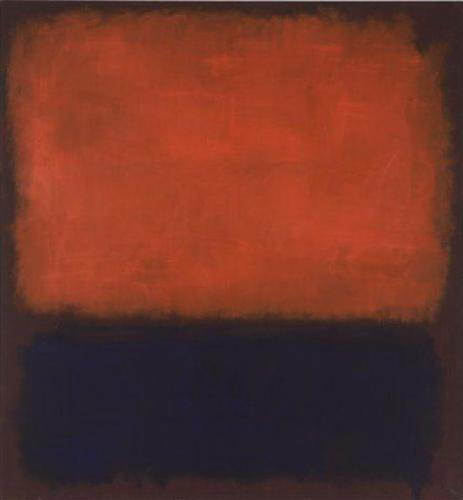If you were to place this artwork in a specific location, where would it be and why? This artwork would be fitting in a contemporary art museum, specifically in a section dedicated to abstract expressionism. Its bold colors and textures make it a compelling piece that invites viewers to engage with its emotional depth and simplicity. Placing it in such a context allows for a better appreciation of its style and historical significance, surrounded by other works that explore similar themes.  Craft a story where this painting serves as a portal to another dimension. In a quiet, dimly-lit gallery, an unsuspecting visitor stumbles upon the painting, mesmerized by its contrasting hues. As they gaze deeper into the textured red and smooth black, they feel an inexplicable pull. Suddenly, the colors swirl together, forming a vortex that draws them in. The visitor finds themselves in a parallel universe where colors define reality. The sky is tinted a rich red, brimming with vibrant energy, while the ground is a serene black, reflecting their innermost thoughts. In this dimension, emotions are tangible, and every step taken alters the landscape, creating textured ridges or smoothing paths depending on their feelings. Here, the visitor learns to navigate their emotions, discovering the profound impact of balance and contrast in their journey, ultimately finding a way back to their world with a renewed understanding of their inner self. 